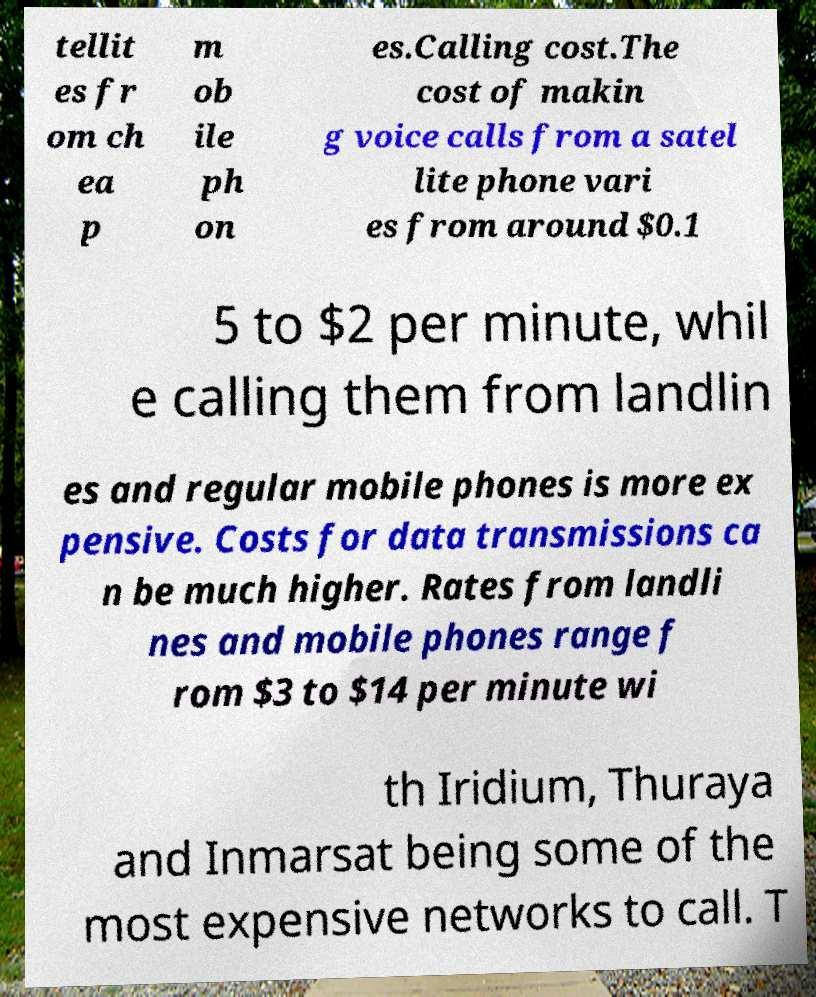I need the written content from this picture converted into text. Can you do that? tellit es fr om ch ea p m ob ile ph on es.Calling cost.The cost of makin g voice calls from a satel lite phone vari es from around $0.1 5 to $2 per minute, whil e calling them from landlin es and regular mobile phones is more ex pensive. Costs for data transmissions ca n be much higher. Rates from landli nes and mobile phones range f rom $3 to $14 per minute wi th Iridium, Thuraya and Inmarsat being some of the most expensive networks to call. T 